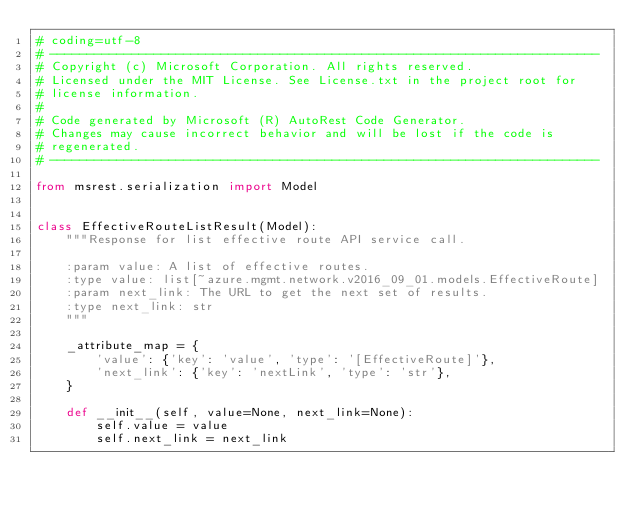Convert code to text. <code><loc_0><loc_0><loc_500><loc_500><_Python_># coding=utf-8
# --------------------------------------------------------------------------
# Copyright (c) Microsoft Corporation. All rights reserved.
# Licensed under the MIT License. See License.txt in the project root for
# license information.
#
# Code generated by Microsoft (R) AutoRest Code Generator.
# Changes may cause incorrect behavior and will be lost if the code is
# regenerated.
# --------------------------------------------------------------------------

from msrest.serialization import Model


class EffectiveRouteListResult(Model):
    """Response for list effective route API service call.

    :param value: A list of effective routes.
    :type value: list[~azure.mgmt.network.v2016_09_01.models.EffectiveRoute]
    :param next_link: The URL to get the next set of results.
    :type next_link: str
    """

    _attribute_map = {
        'value': {'key': 'value', 'type': '[EffectiveRoute]'},
        'next_link': {'key': 'nextLink', 'type': 'str'},
    }

    def __init__(self, value=None, next_link=None):
        self.value = value
        self.next_link = next_link
</code> 